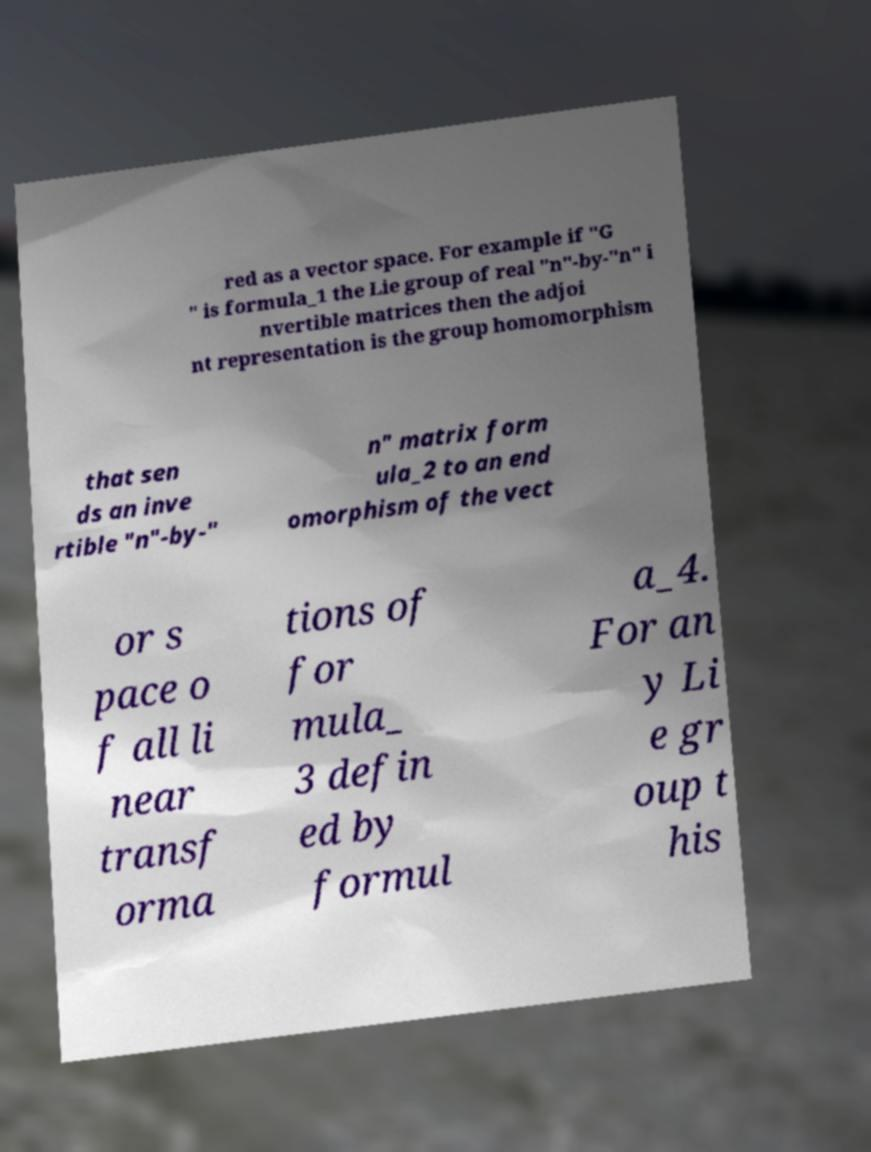Could you assist in decoding the text presented in this image and type it out clearly? red as a vector space. For example if "G " is formula_1 the Lie group of real "n"-by-"n" i nvertible matrices then the adjoi nt representation is the group homomorphism that sen ds an inve rtible "n"-by-" n" matrix form ula_2 to an end omorphism of the vect or s pace o f all li near transf orma tions of for mula_ 3 defin ed by formul a_4. For an y Li e gr oup t his 